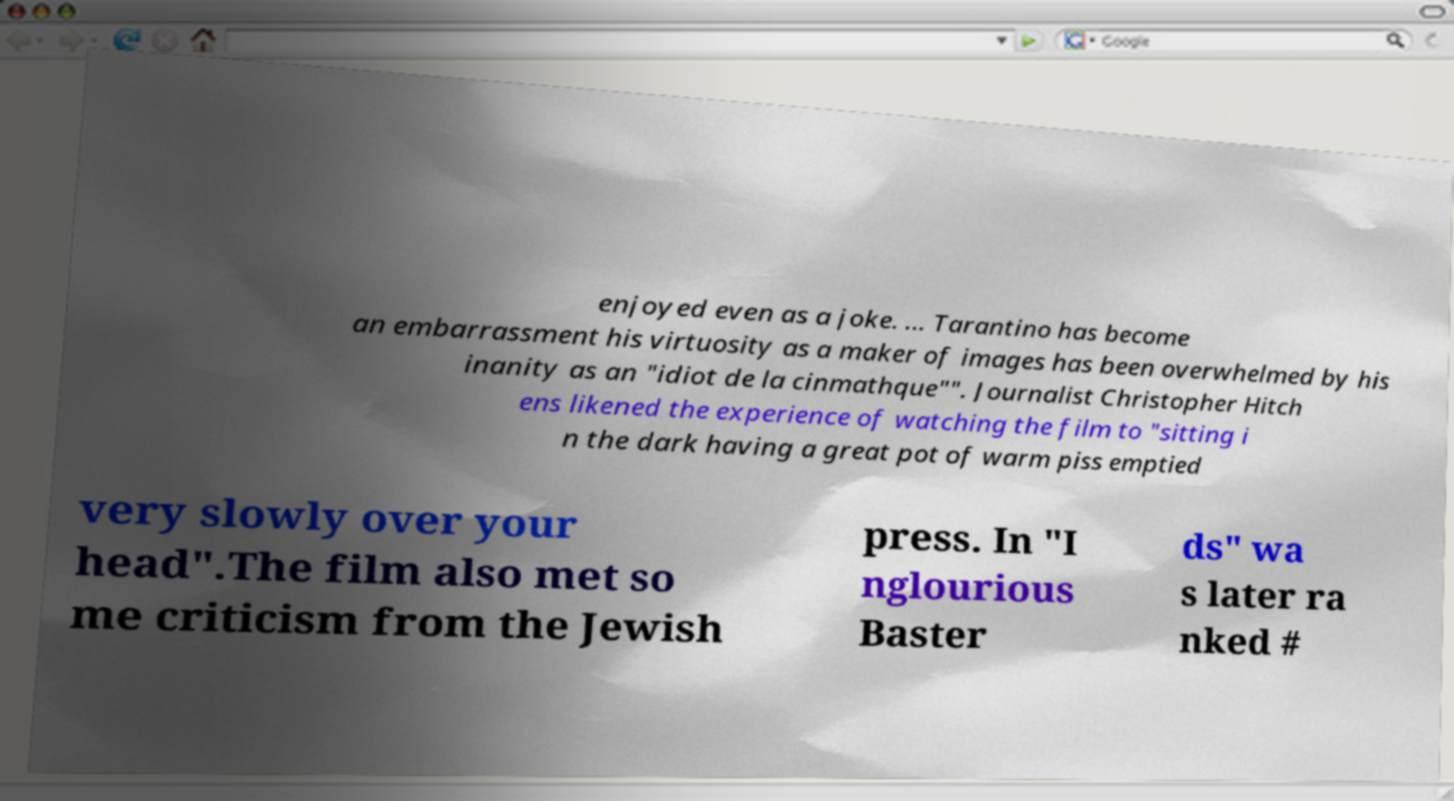Please identify and transcribe the text found in this image. enjoyed even as a joke. ... Tarantino has become an embarrassment his virtuosity as a maker of images has been overwhelmed by his inanity as an "idiot de la cinmathque"". Journalist Christopher Hitch ens likened the experience of watching the film to "sitting i n the dark having a great pot of warm piss emptied very slowly over your head".The film also met so me criticism from the Jewish press. In "I nglourious Baster ds" wa s later ra nked # 